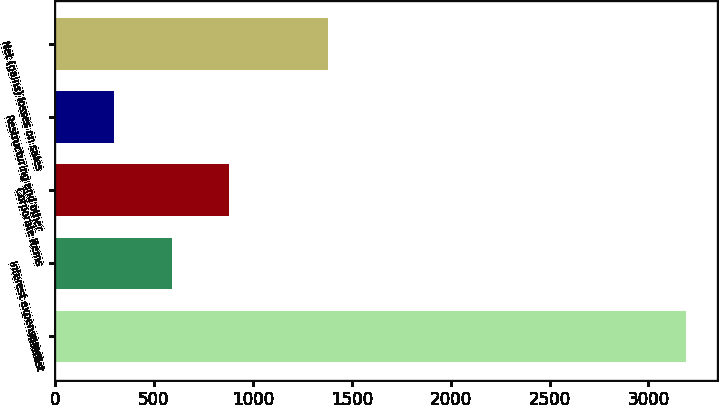Convert chart. <chart><loc_0><loc_0><loc_500><loc_500><bar_chart><fcel>Interest<fcel>Interest expense net<fcel>Corporate items<fcel>Restructuring and other<fcel>Net (gains) losses on sales<nl><fcel>3188<fcel>588.8<fcel>877.6<fcel>300<fcel>1381<nl></chart> 